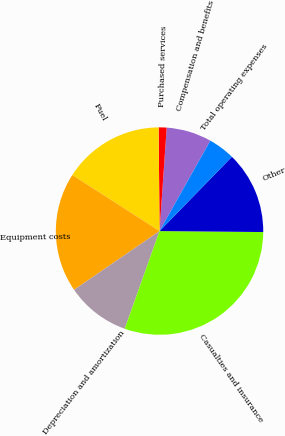Convert chart. <chart><loc_0><loc_0><loc_500><loc_500><pie_chart><fcel>Compensation and benefits<fcel>Purchased services<fcel>Fuel<fcel>Equipment costs<fcel>Depreciation and amortization<fcel>Casualties and insurance<fcel>Other<fcel>Total operating expenses<nl><fcel>7.05%<fcel>1.24%<fcel>15.77%<fcel>18.68%<fcel>9.96%<fcel>30.3%<fcel>12.86%<fcel>4.14%<nl></chart> 